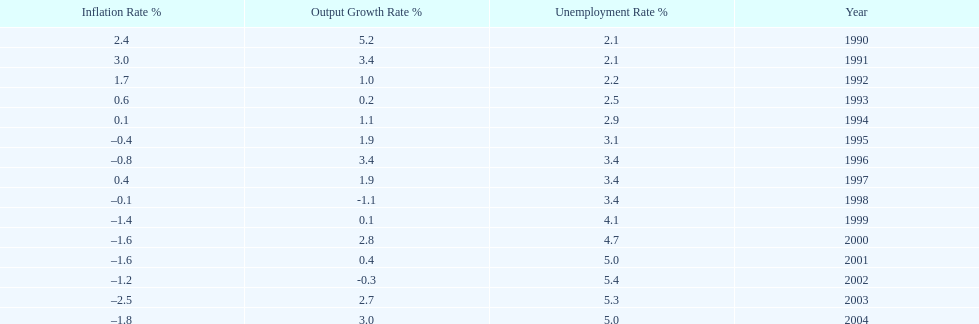When in the 1990's did the inflation rate first become negative? 1995. 